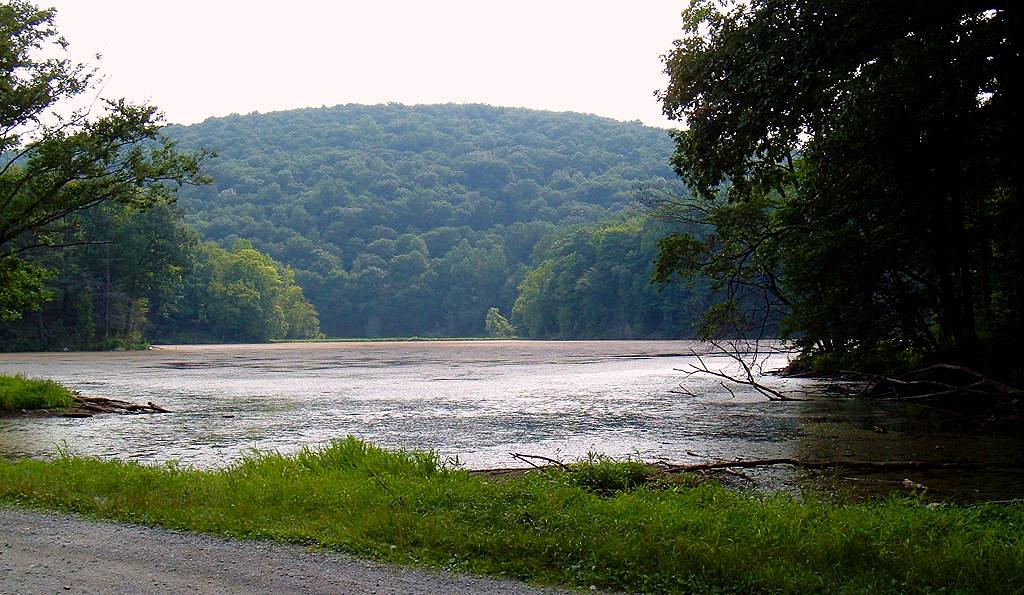What type of water body is present in the image? There is a river in the image. What type of vegetation can be seen on the land? There is grass on the land. What type of pathway is visible in the image? There is a road in the image. What can be seen in the background of the image? There are trees, a hill, and the sky visible in the background of the image. What type of writer is sitting on the horse in the image? There is no writer or horse present in the image. What type of cover is protecting the river in the image? There is no cover present in the image; the river is not protected by any cover. 